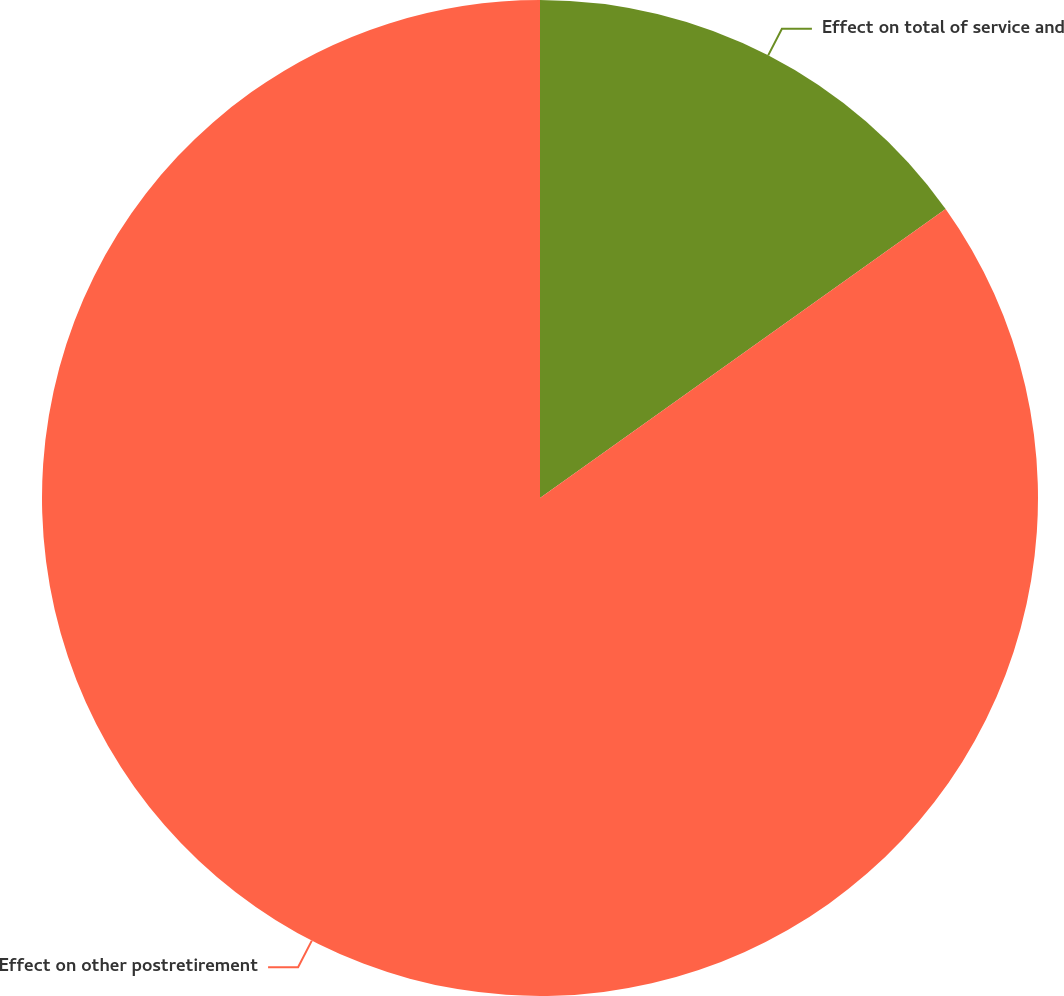Convert chart to OTSL. <chart><loc_0><loc_0><loc_500><loc_500><pie_chart><fcel>Effect on total of service and<fcel>Effect on other postretirement<nl><fcel>15.15%<fcel>84.85%<nl></chart> 